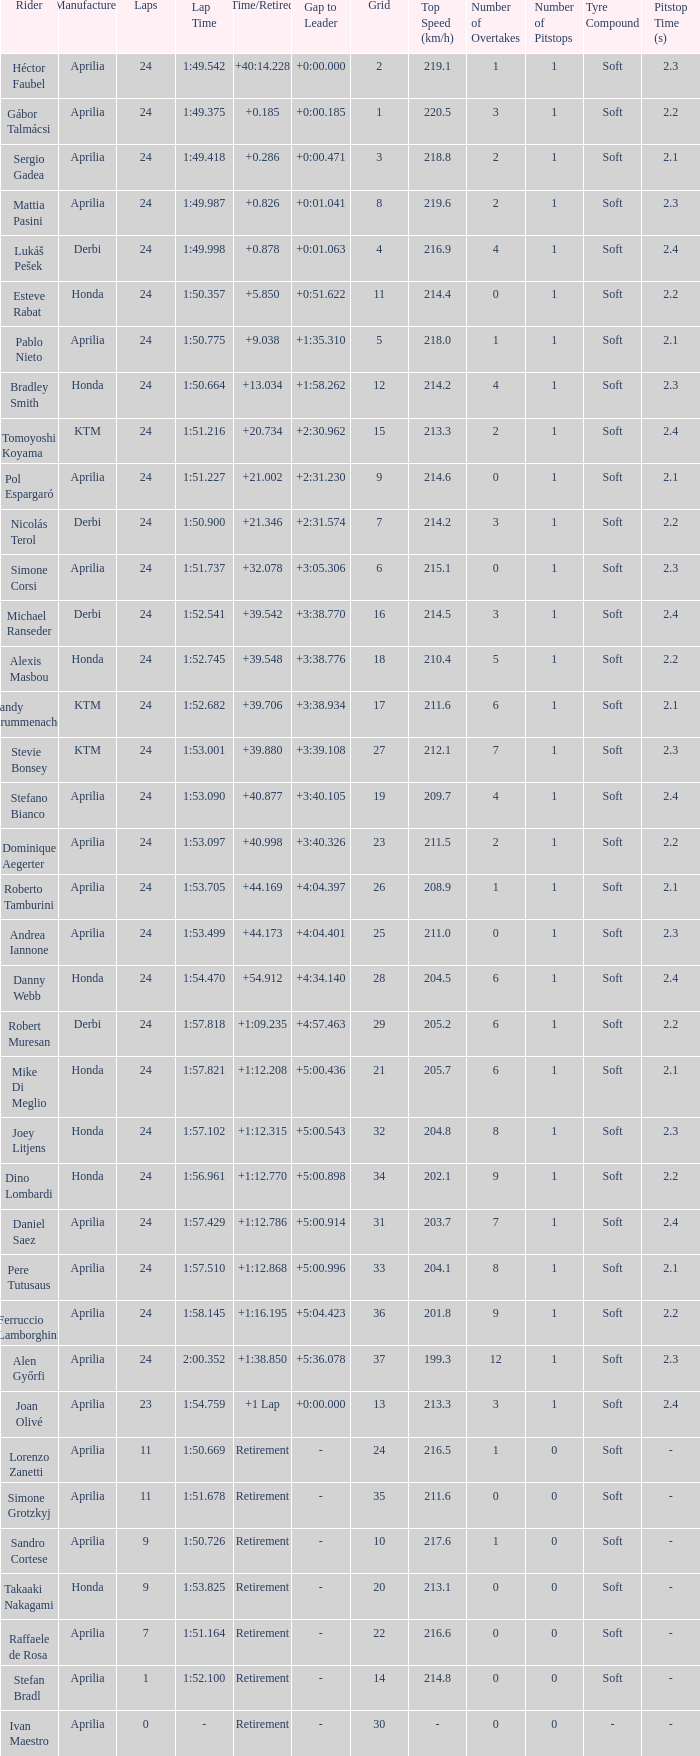How many grids correspond to more than 24 laps? None. 